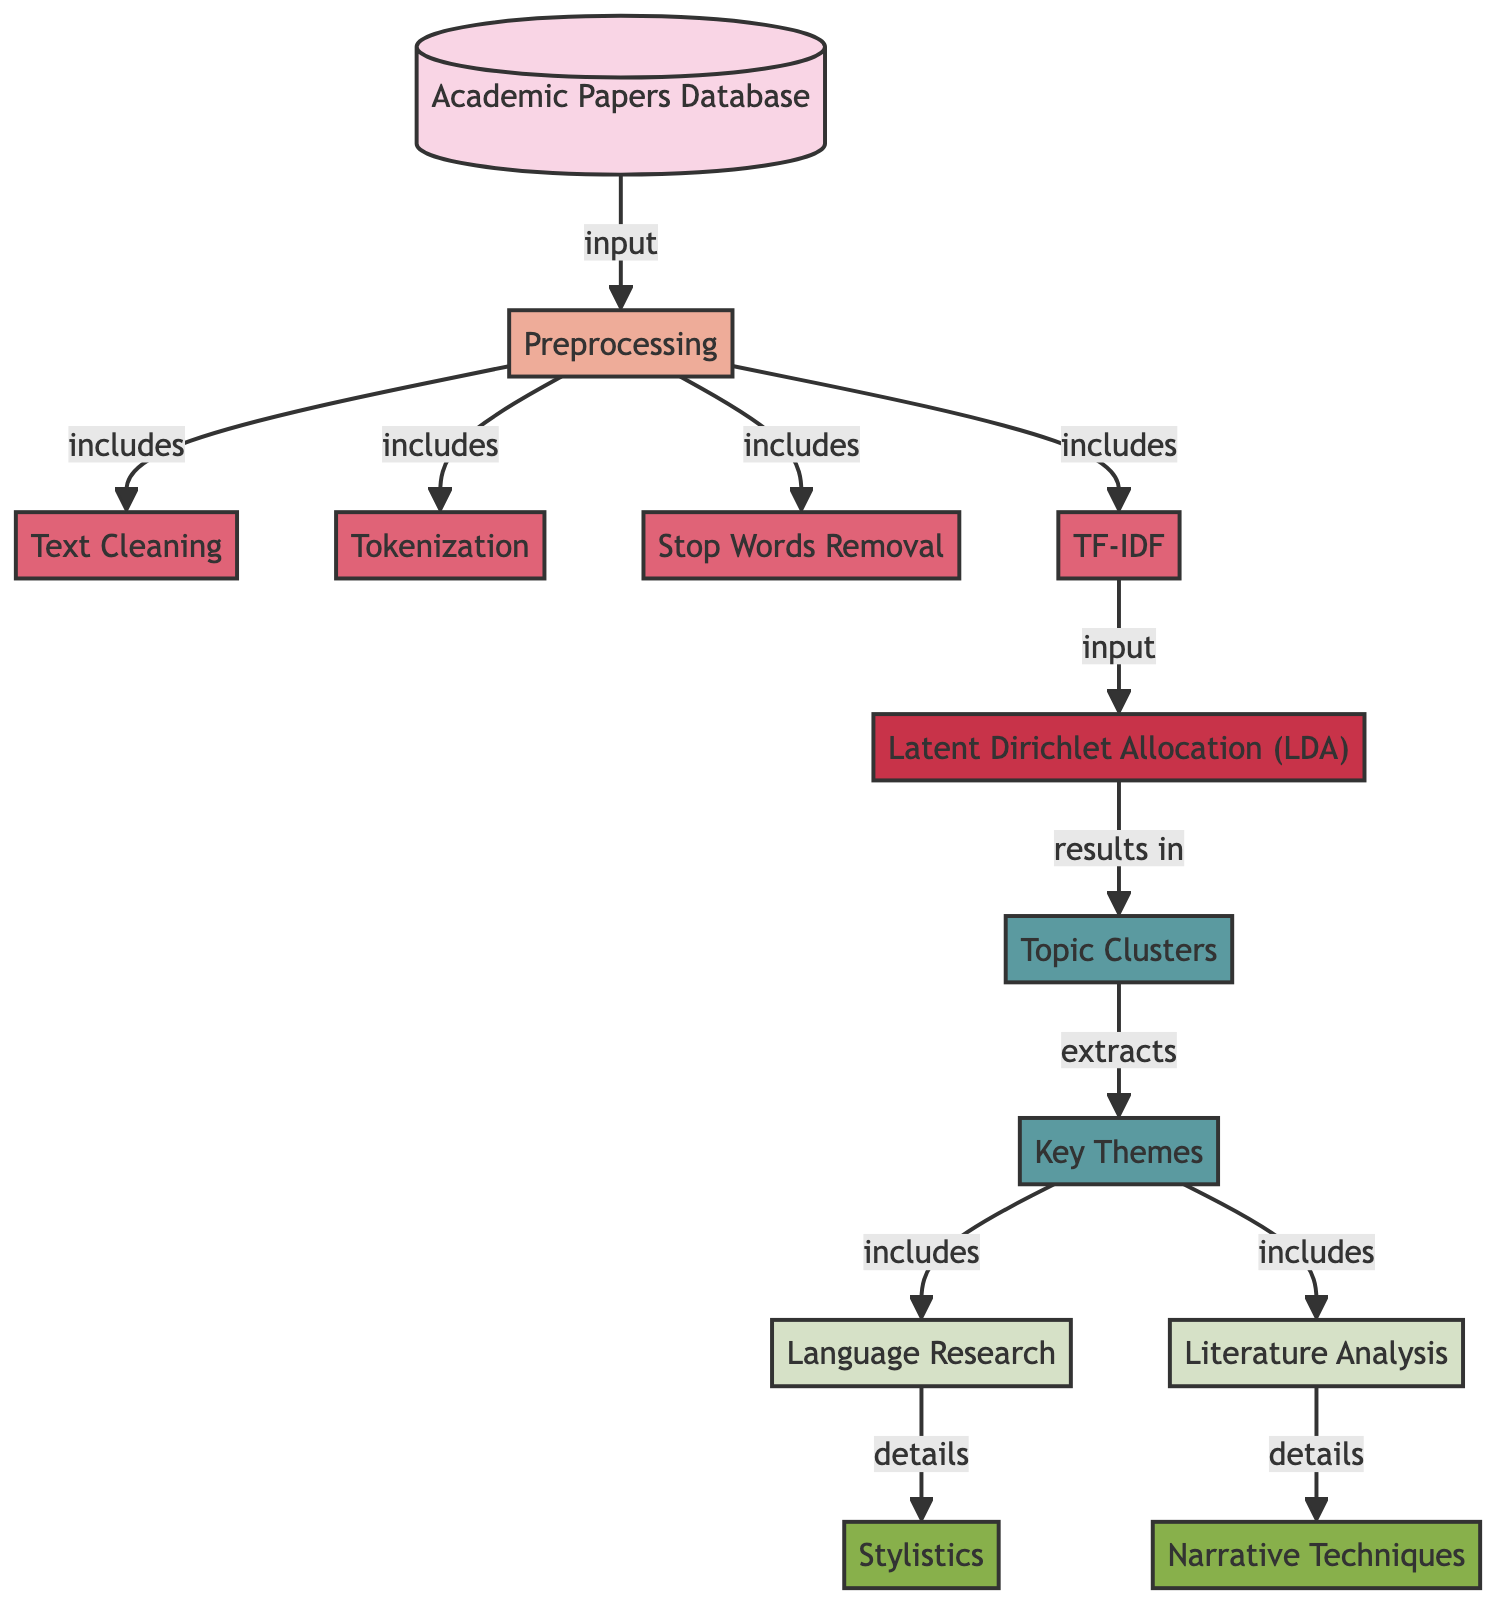What is the input source for the diagram? The diagram indicates that the first node titled "Academic Papers Database" acts as the input source for the entire flow of the process.
Answer: Academic Papers Database What is the last stage of the diagram? The final nodes in the flow represent "Key Themes," which are the outcomes derived from the prior steps in the diagram.
Answer: Key Themes How many tasks are involved in the preprocessing stage? The preprocessing stage consists of four tasks: Text Cleaning, Tokenization, Stop Words Removal, and TF-IDF, as shown directly linked under the "Preprocessing" node.
Answer: Four What is the result obtained after applying LDA? The application of Latent Dirichlet Allocation results in "Topic Clusters," which can be identified directly in the sequence following the LDA node in the diagram.
Answer: Topic Clusters Which theme details "Narrative Techniques"? Under the node "Literature Analysis," the sub-theme "Narrative Techniques" is specifically indicated as a detailed area within that theme.
Answer: Narrative Techniques What is the relationship between TF-IDF and LDA in the diagram? The diagram shows a directional edge from "TF-IDF" to "Latent Dirichlet Allocation (LDA)," indicating that TF-IDF serves as an input for LDA to process.
Answer: Input How many themes are extracted from the topic clusters? The diagram indicates two main themes, namely "Language Research" and "Literature Analysis," both of which are derived from the node "Topic Clusters."
Answer: Two Which task follows Stop Words Removal? The task that directly follows "Stop Words Removal" in the flow is "TF-IDF," as indicated by the connections within the preprocessing section of the diagram.
Answer: TF-IDF What type of diagram is being represented? The diagram is classified as a "Machine Learning Diagram," which is further evidenced by its focus on topics and modeling techniques used for analyzing data.
Answer: Machine Learning Diagram 